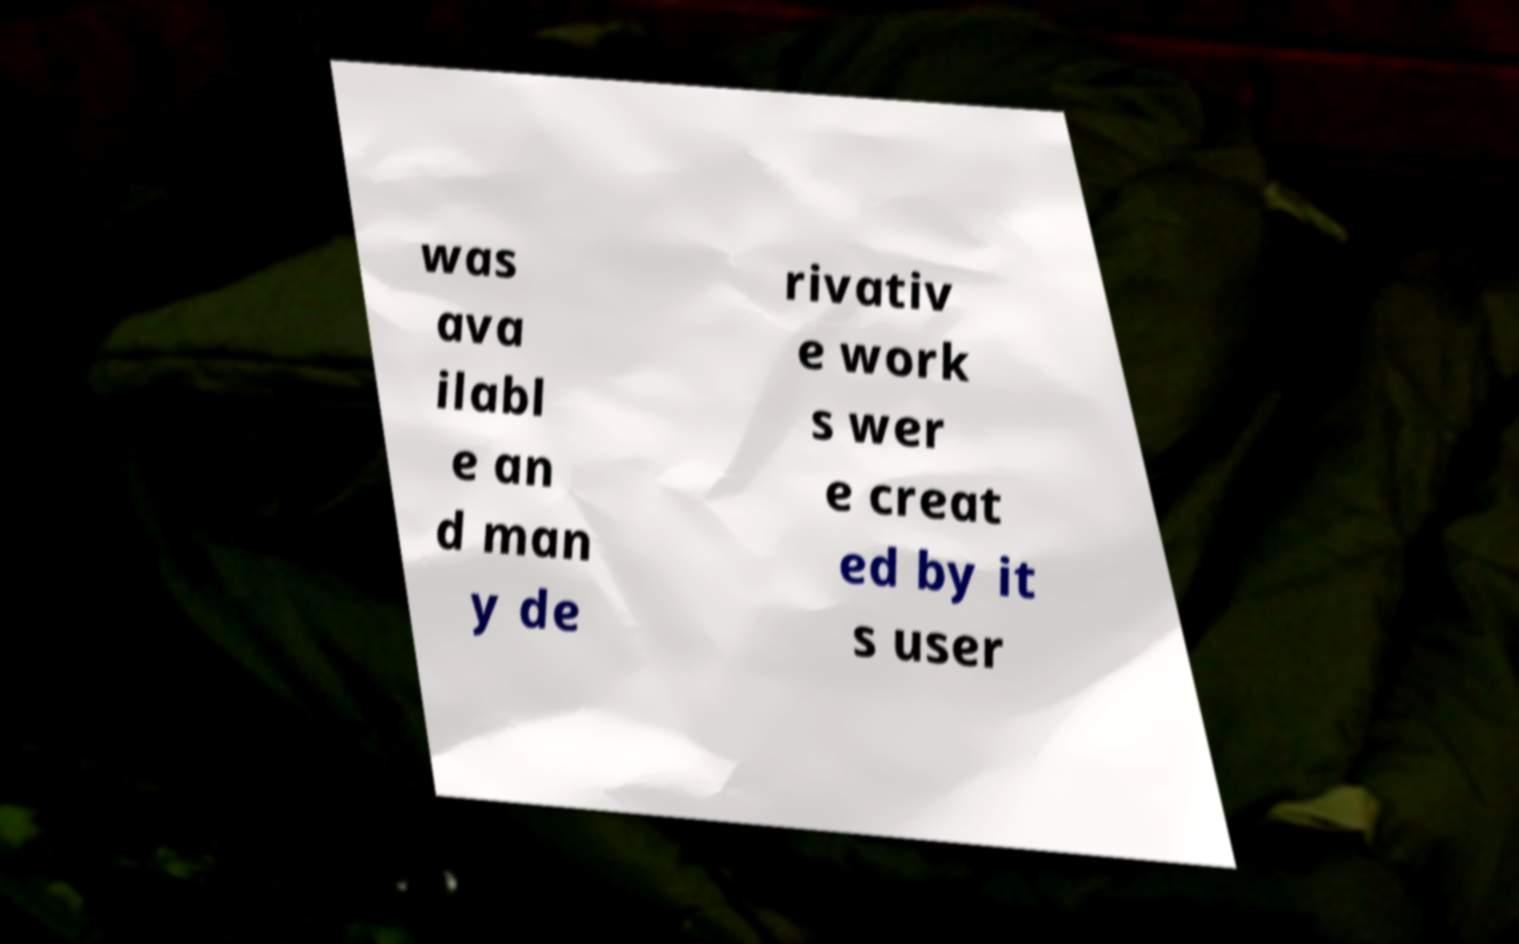Please read and relay the text visible in this image. What does it say? was ava ilabl e an d man y de rivativ e work s wer e creat ed by it s user 